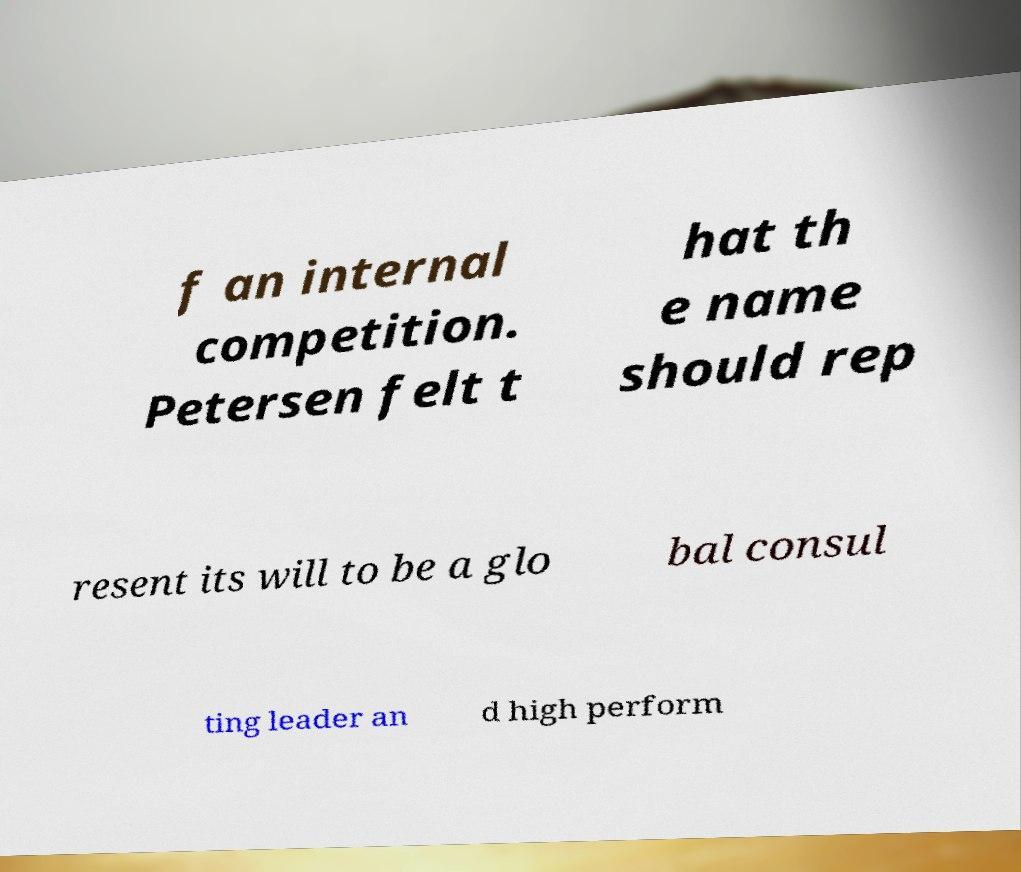What messages or text are displayed in this image? I need them in a readable, typed format. f an internal competition. Petersen felt t hat th e name should rep resent its will to be a glo bal consul ting leader an d high perform 